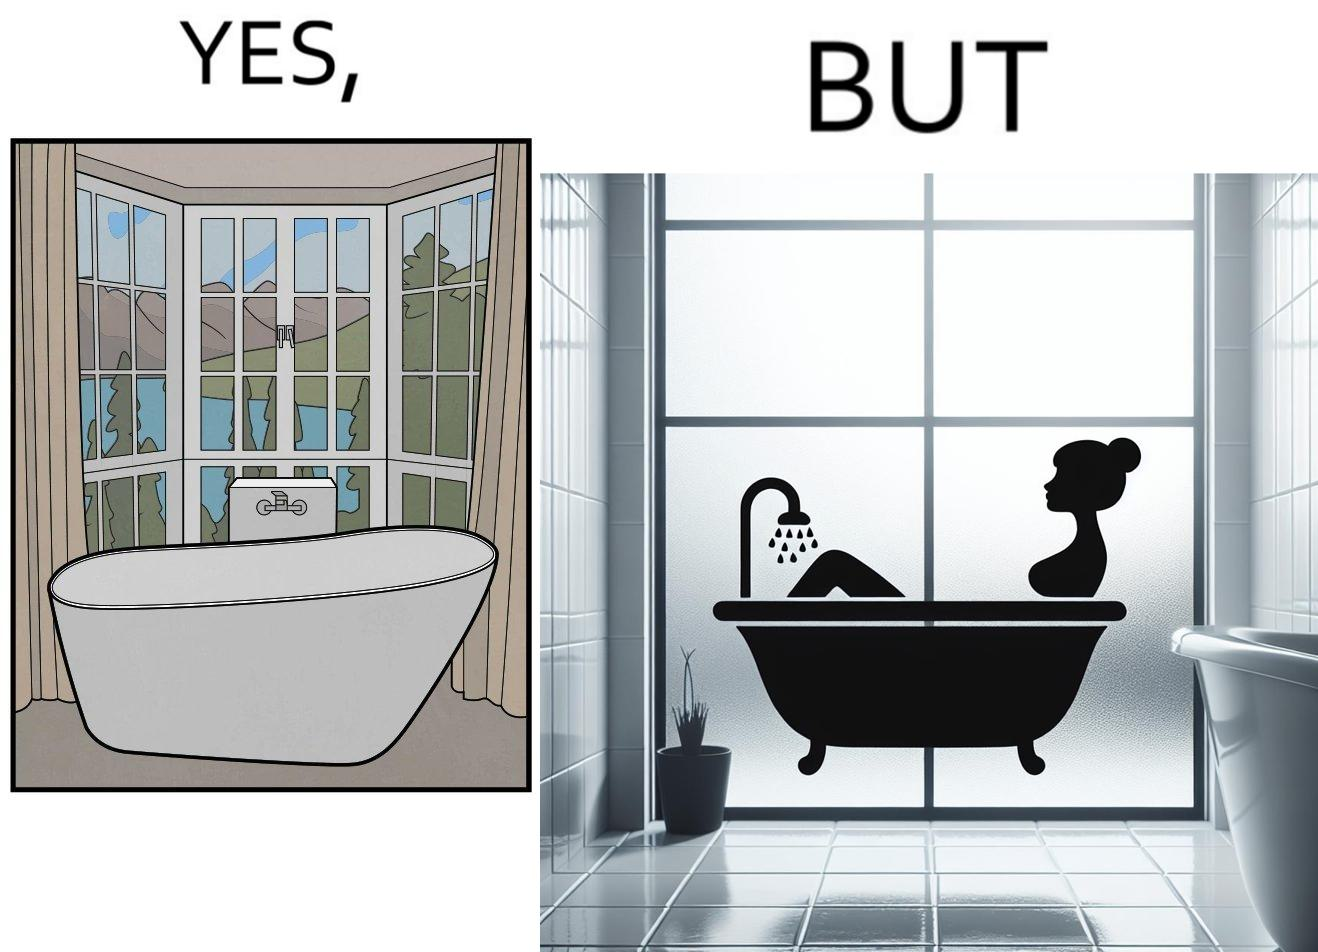Is this image satirical or non-satirical? Yes, this image is satirical. 